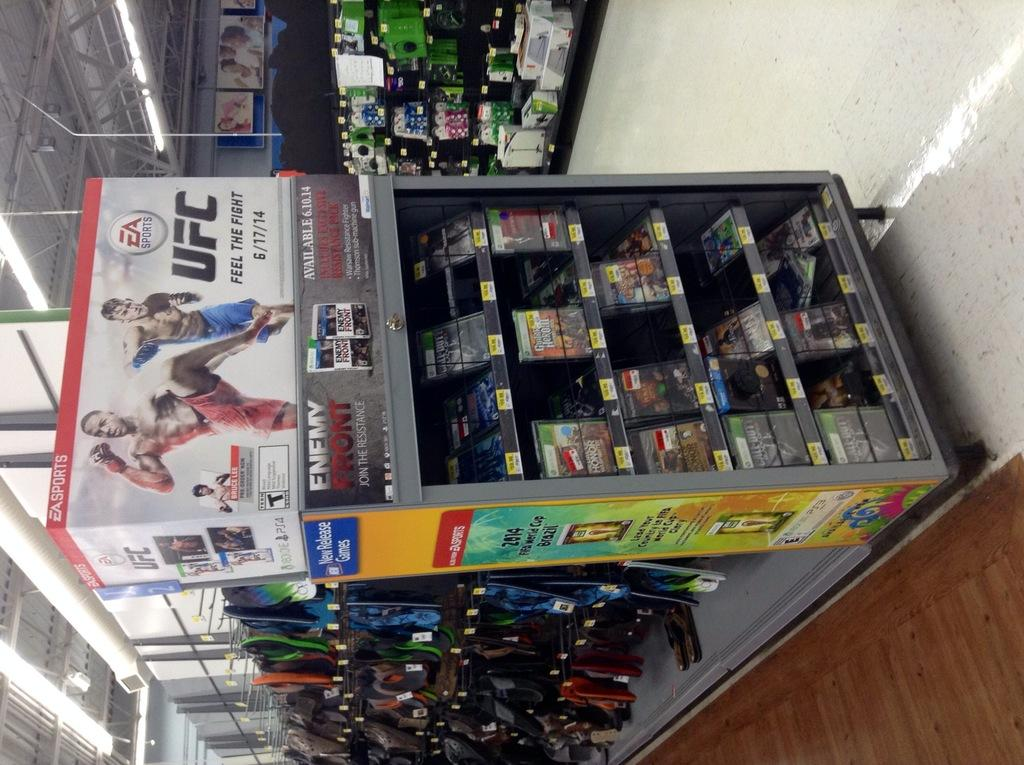<image>
Summarize the visual content of the image. A display of products with a UFC poster above it. 